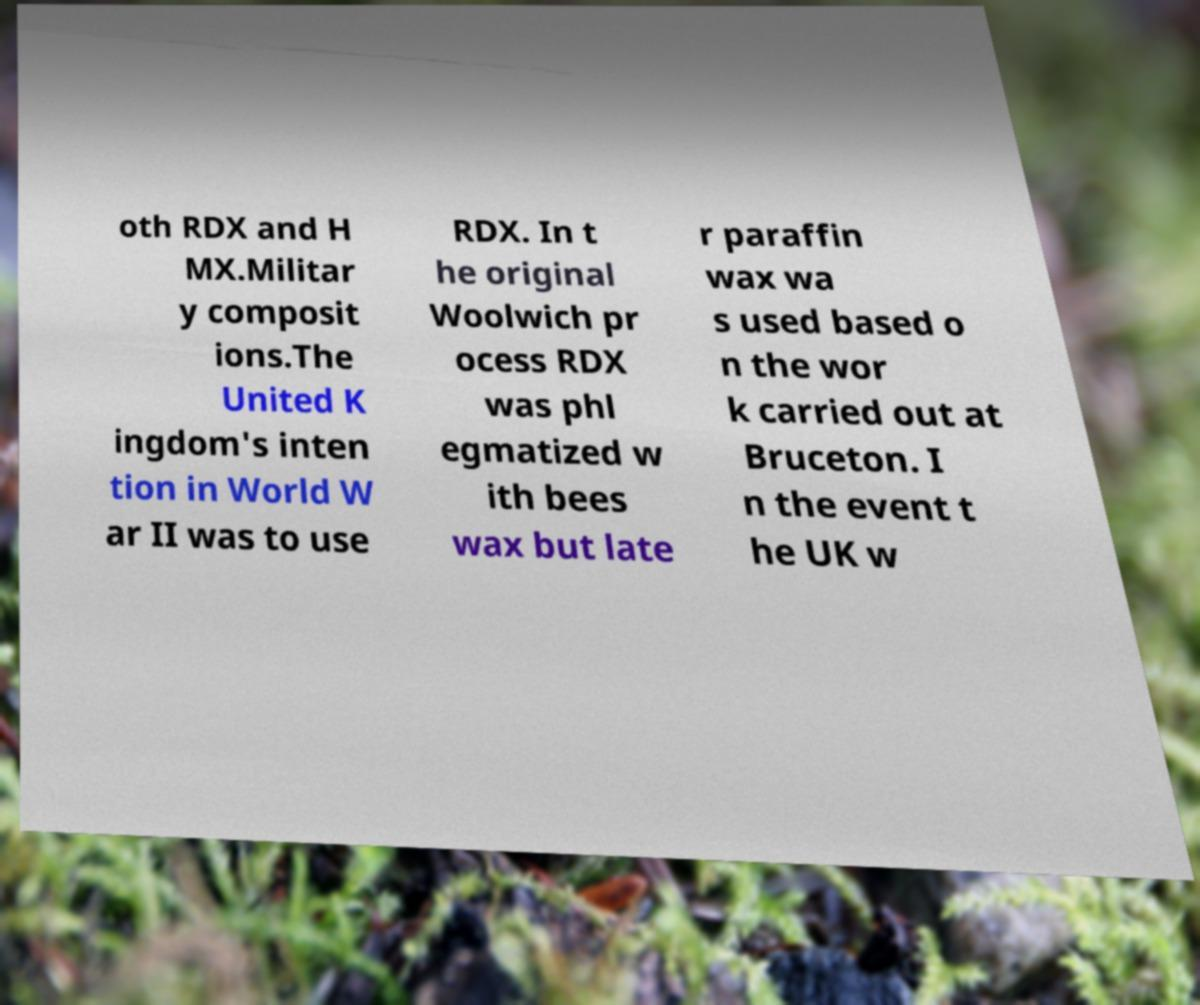There's text embedded in this image that I need extracted. Can you transcribe it verbatim? oth RDX and H MX.Militar y composit ions.The United K ingdom's inten tion in World W ar II was to use RDX. In t he original Woolwich pr ocess RDX was phl egmatized w ith bees wax but late r paraffin wax wa s used based o n the wor k carried out at Bruceton. I n the event t he UK w 